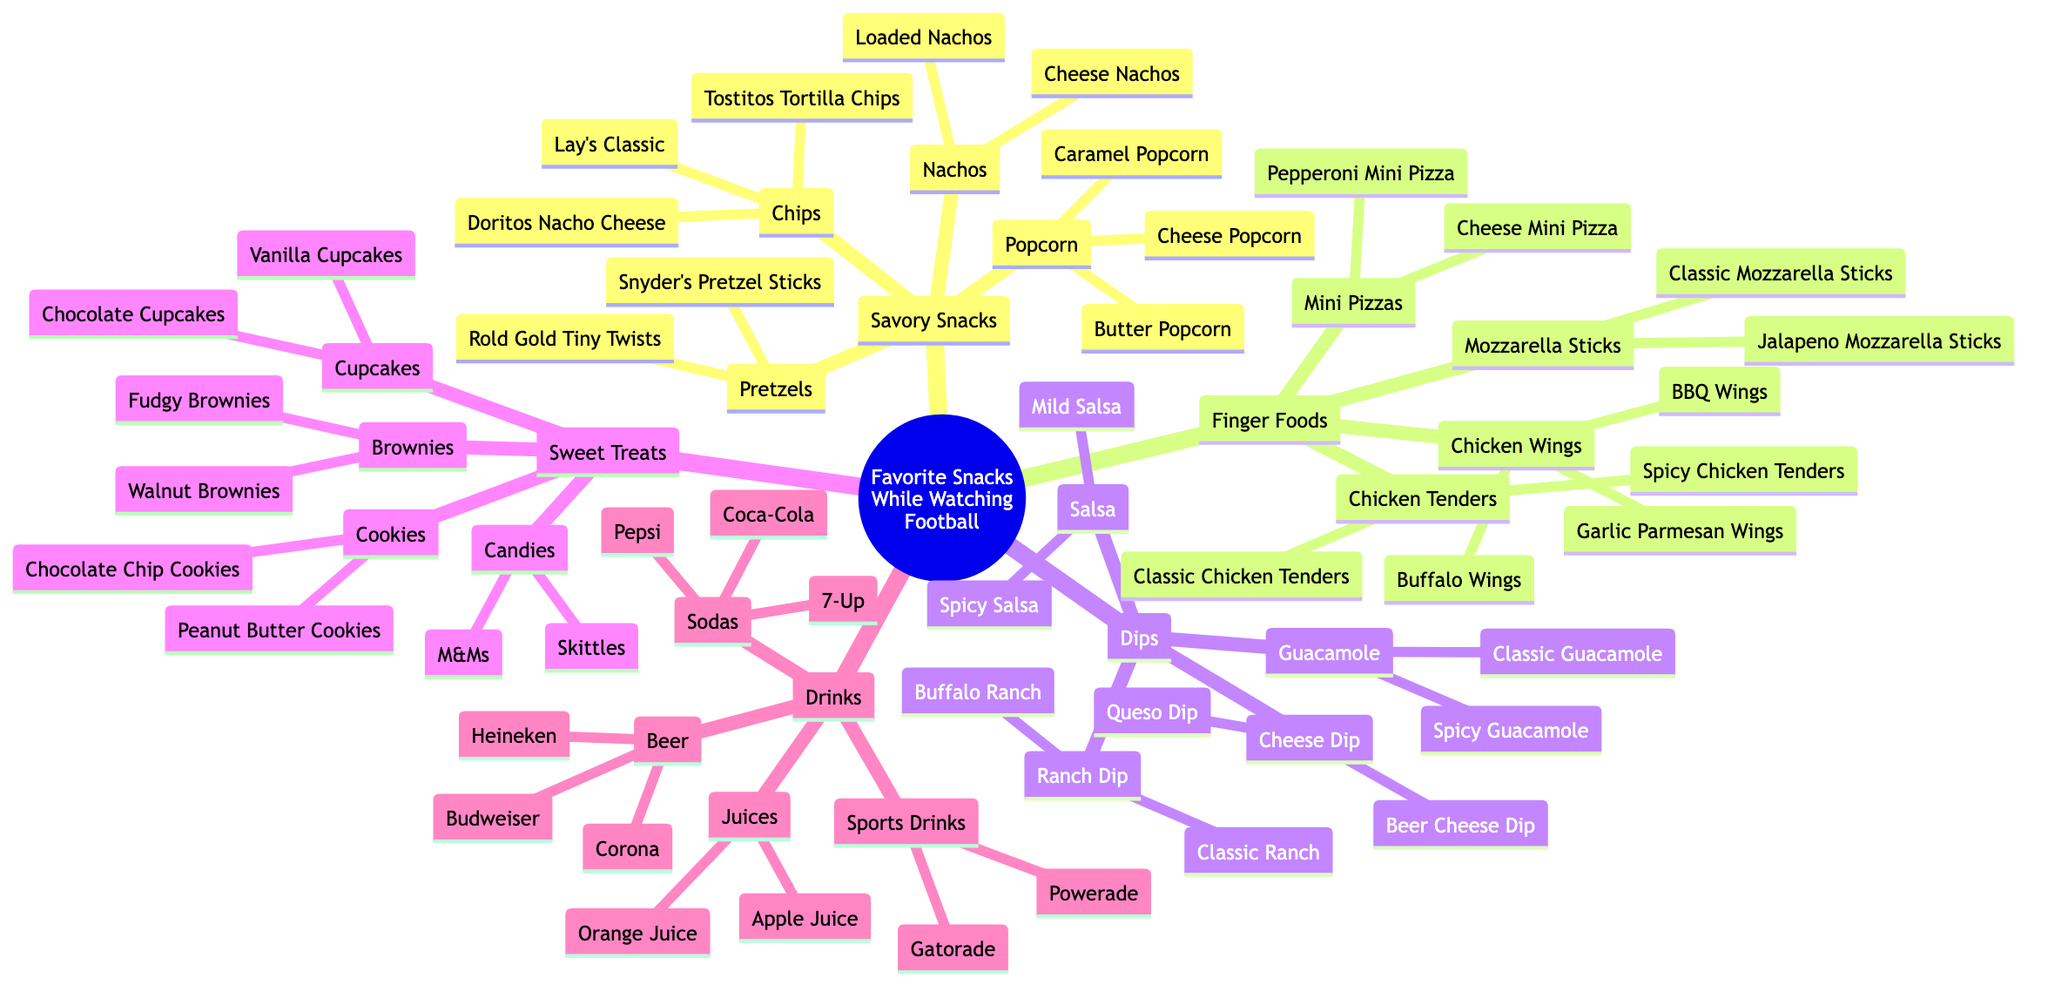What are the two main categories of snacks? The diagram displays several categories, but the two main categories visible in the first layer are "Savory Snacks" and "Finger Foods".
Answer: Savory Snacks, Finger Foods How many types of dips are listed? Counting the dip nodes directly from the diagram, we see there are four types of dips: Cheese Dip, Salsa, Guacamole, and Ranch Dip.
Answer: 4 Which snack has the most options? By inspecting the snack categories, "Chicken Wings" under Finger Foods is the category with the highest number of options listed: Buffalo Wings, BBQ Wings, and Garlic Parmesan Wings.
Answer: Chicken Wings What are the two types of popcorn mentioned? From examining the Popcorn node within the Savory Snacks category, the two types explicitly stated are Butter Popcorn and Cheese Popcorn.
Answer: Butter Popcorn, Cheese Popcorn Which drinks are categorized under Sodas? The Sodas node includes three types of drinks specifically listed: Coca-Cola, Pepsi, and 7-Up.
Answer: Coca-Cola, Pepsi, 7-Up Which snack under Sweet Treats includes chocolate? Within Sweet Treats, two snacks explicitly include chocolate: Chocolate Chip Cookies and Chocolate Cupcakes.
Answer: Chocolate Chip Cookies, Chocolate Cupcakes Which type of wings is specifically mentioned in the diagram? Under the Chicken Wings node within Finger Foods, the wings mentioned include Buffalo Wings, BBQ Wings, and Garlic Parmesan Wings.
Answer: Buffalo Wings How many options does the "Savory Snacks" category have in total? Counting all the options from the Chips, Popcorn, Pretzels, and Nachos nodes together, we find: 3 + 3 + 2 + 2 = 10 options total in the Savory Snacks category.
Answer: 10 What kind of juice is listed under Drinks? The Juices node in the Drinks category lists two options: Orange Juice and Apple Juice.
Answer: Orange Juice, Apple Juice 